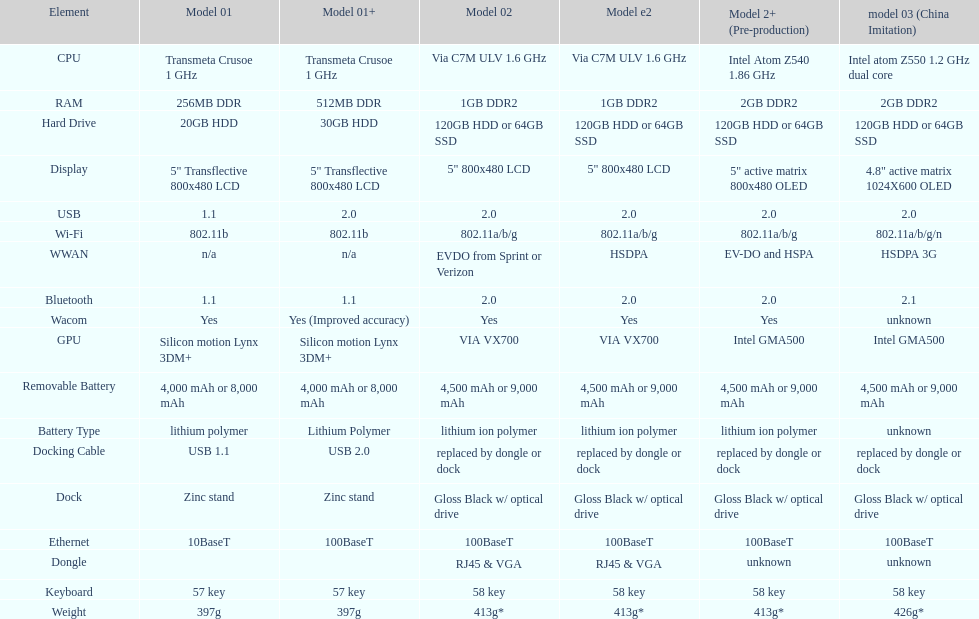How many models use a usb docking cable? 2. 